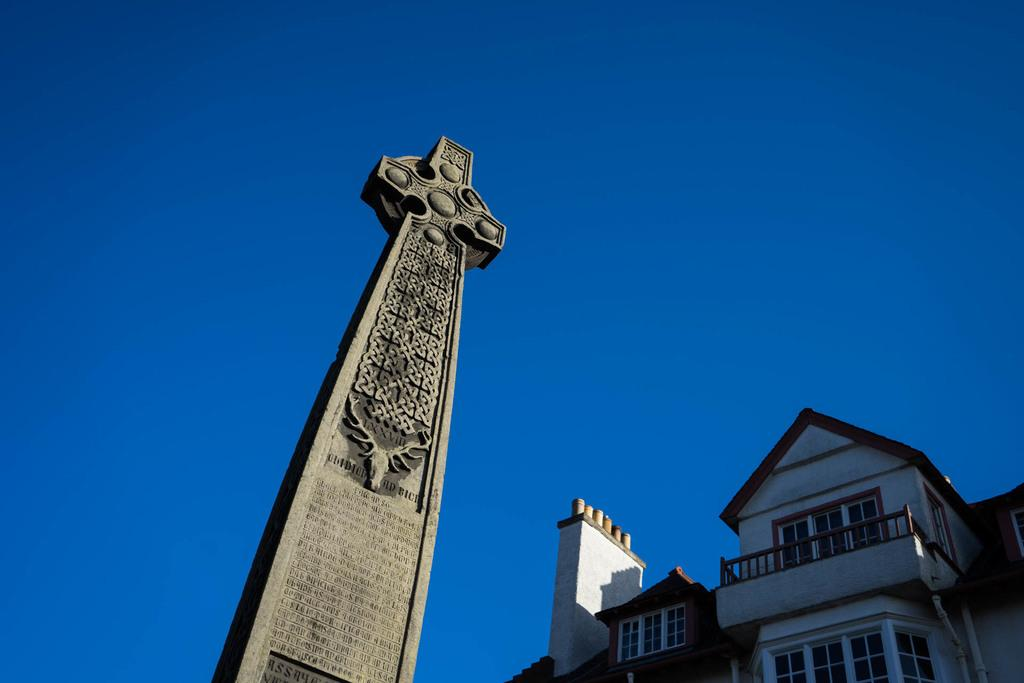What structure is located on the bottom left side of the image? There is a building on the bottom left side of the image. What is in front of the building? There is a rock structure with images and text in front of the building. What can be seen in the background of the image? The sky is visible in the background of the image. How many apples are on the truck in the image? There is no truck or apples present in the image. What type of houses can be seen near the building in the image? There is no mention of houses in the image; it only features a building and a rock structure with images and text. 